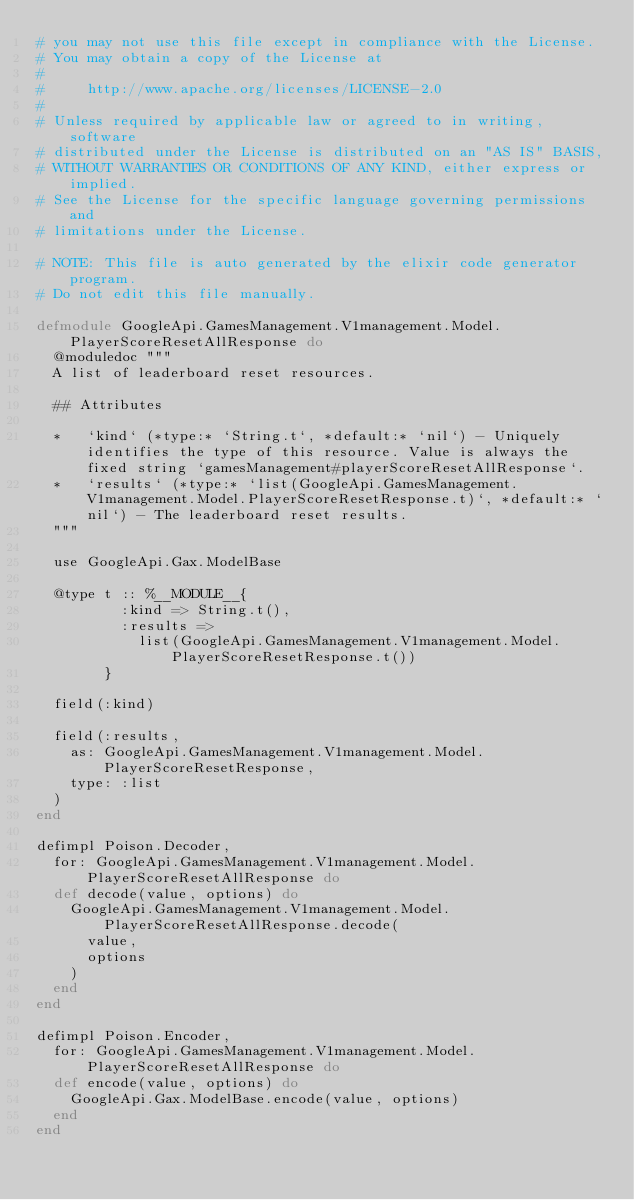Convert code to text. <code><loc_0><loc_0><loc_500><loc_500><_Elixir_># you may not use this file except in compliance with the License.
# You may obtain a copy of the License at
#
#     http://www.apache.org/licenses/LICENSE-2.0
#
# Unless required by applicable law or agreed to in writing, software
# distributed under the License is distributed on an "AS IS" BASIS,
# WITHOUT WARRANTIES OR CONDITIONS OF ANY KIND, either express or implied.
# See the License for the specific language governing permissions and
# limitations under the License.

# NOTE: This file is auto generated by the elixir code generator program.
# Do not edit this file manually.

defmodule GoogleApi.GamesManagement.V1management.Model.PlayerScoreResetAllResponse do
  @moduledoc """
  A list of leaderboard reset resources.

  ## Attributes

  *   `kind` (*type:* `String.t`, *default:* `nil`) - Uniquely identifies the type of this resource. Value is always the fixed string `gamesManagement#playerScoreResetAllResponse`.
  *   `results` (*type:* `list(GoogleApi.GamesManagement.V1management.Model.PlayerScoreResetResponse.t)`, *default:* `nil`) - The leaderboard reset results.
  """

  use GoogleApi.Gax.ModelBase

  @type t :: %__MODULE__{
          :kind => String.t(),
          :results =>
            list(GoogleApi.GamesManagement.V1management.Model.PlayerScoreResetResponse.t())
        }

  field(:kind)

  field(:results,
    as: GoogleApi.GamesManagement.V1management.Model.PlayerScoreResetResponse,
    type: :list
  )
end

defimpl Poison.Decoder,
  for: GoogleApi.GamesManagement.V1management.Model.PlayerScoreResetAllResponse do
  def decode(value, options) do
    GoogleApi.GamesManagement.V1management.Model.PlayerScoreResetAllResponse.decode(
      value,
      options
    )
  end
end

defimpl Poison.Encoder,
  for: GoogleApi.GamesManagement.V1management.Model.PlayerScoreResetAllResponse do
  def encode(value, options) do
    GoogleApi.Gax.ModelBase.encode(value, options)
  end
end
</code> 